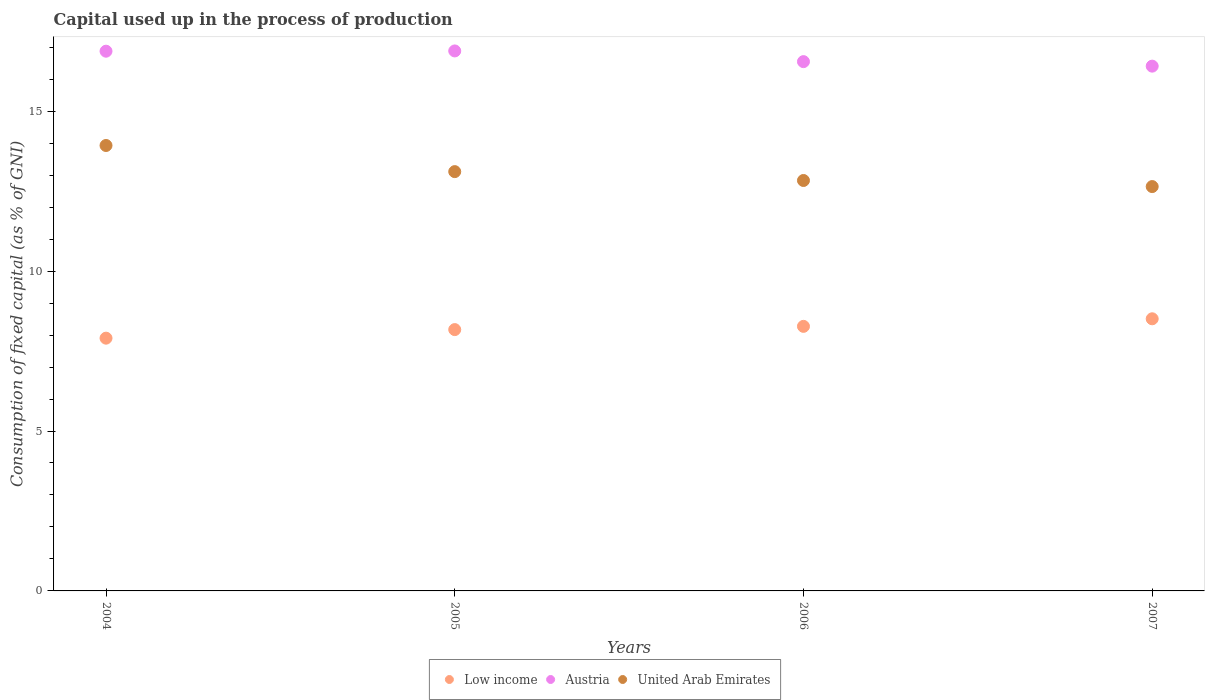What is the capital used up in the process of production in United Arab Emirates in 2005?
Your answer should be compact. 13.11. Across all years, what is the maximum capital used up in the process of production in United Arab Emirates?
Provide a short and direct response. 13.93. Across all years, what is the minimum capital used up in the process of production in United Arab Emirates?
Provide a succinct answer. 12.64. In which year was the capital used up in the process of production in United Arab Emirates minimum?
Keep it short and to the point. 2007. What is the total capital used up in the process of production in United Arab Emirates in the graph?
Provide a short and direct response. 52.51. What is the difference between the capital used up in the process of production in Austria in 2005 and that in 2007?
Provide a succinct answer. 0.48. What is the difference between the capital used up in the process of production in United Arab Emirates in 2006 and the capital used up in the process of production in Low income in 2007?
Provide a short and direct response. 4.32. What is the average capital used up in the process of production in Low income per year?
Make the answer very short. 8.21. In the year 2006, what is the difference between the capital used up in the process of production in Low income and capital used up in the process of production in Austria?
Keep it short and to the point. -8.28. What is the ratio of the capital used up in the process of production in Low income in 2005 to that in 2006?
Make the answer very short. 0.99. Is the capital used up in the process of production in Austria in 2004 less than that in 2007?
Provide a succinct answer. No. What is the difference between the highest and the second highest capital used up in the process of production in Austria?
Your response must be concise. 0.01. What is the difference between the highest and the lowest capital used up in the process of production in Austria?
Your answer should be very brief. 0.48. In how many years, is the capital used up in the process of production in United Arab Emirates greater than the average capital used up in the process of production in United Arab Emirates taken over all years?
Keep it short and to the point. 1. Is the sum of the capital used up in the process of production in United Arab Emirates in 2005 and 2007 greater than the maximum capital used up in the process of production in Low income across all years?
Ensure brevity in your answer.  Yes. Is it the case that in every year, the sum of the capital used up in the process of production in United Arab Emirates and capital used up in the process of production in Low income  is greater than the capital used up in the process of production in Austria?
Keep it short and to the point. Yes. Is the capital used up in the process of production in United Arab Emirates strictly greater than the capital used up in the process of production in Austria over the years?
Your answer should be very brief. No. Is the capital used up in the process of production in Low income strictly less than the capital used up in the process of production in Austria over the years?
Your answer should be compact. Yes. How many dotlines are there?
Make the answer very short. 3. How many years are there in the graph?
Ensure brevity in your answer.  4. Does the graph contain grids?
Offer a terse response. No. Where does the legend appear in the graph?
Give a very brief answer. Bottom center. How are the legend labels stacked?
Your answer should be compact. Horizontal. What is the title of the graph?
Your answer should be compact. Capital used up in the process of production. What is the label or title of the X-axis?
Provide a short and direct response. Years. What is the label or title of the Y-axis?
Give a very brief answer. Consumption of fixed capital (as % of GNI). What is the Consumption of fixed capital (as % of GNI) in Low income in 2004?
Give a very brief answer. 7.9. What is the Consumption of fixed capital (as % of GNI) of Austria in 2004?
Give a very brief answer. 16.88. What is the Consumption of fixed capital (as % of GNI) in United Arab Emirates in 2004?
Offer a very short reply. 13.93. What is the Consumption of fixed capital (as % of GNI) of Low income in 2005?
Provide a short and direct response. 8.17. What is the Consumption of fixed capital (as % of GNI) of Austria in 2005?
Your answer should be compact. 16.88. What is the Consumption of fixed capital (as % of GNI) of United Arab Emirates in 2005?
Keep it short and to the point. 13.11. What is the Consumption of fixed capital (as % of GNI) of Low income in 2006?
Your response must be concise. 8.27. What is the Consumption of fixed capital (as % of GNI) in Austria in 2006?
Keep it short and to the point. 16.55. What is the Consumption of fixed capital (as % of GNI) of United Arab Emirates in 2006?
Your answer should be very brief. 12.83. What is the Consumption of fixed capital (as % of GNI) in Low income in 2007?
Provide a short and direct response. 8.51. What is the Consumption of fixed capital (as % of GNI) in Austria in 2007?
Keep it short and to the point. 16.41. What is the Consumption of fixed capital (as % of GNI) in United Arab Emirates in 2007?
Ensure brevity in your answer.  12.64. Across all years, what is the maximum Consumption of fixed capital (as % of GNI) of Low income?
Keep it short and to the point. 8.51. Across all years, what is the maximum Consumption of fixed capital (as % of GNI) of Austria?
Your answer should be very brief. 16.88. Across all years, what is the maximum Consumption of fixed capital (as % of GNI) of United Arab Emirates?
Your response must be concise. 13.93. Across all years, what is the minimum Consumption of fixed capital (as % of GNI) of Low income?
Provide a succinct answer. 7.9. Across all years, what is the minimum Consumption of fixed capital (as % of GNI) of Austria?
Your response must be concise. 16.41. Across all years, what is the minimum Consumption of fixed capital (as % of GNI) in United Arab Emirates?
Ensure brevity in your answer.  12.64. What is the total Consumption of fixed capital (as % of GNI) of Low income in the graph?
Ensure brevity in your answer.  32.85. What is the total Consumption of fixed capital (as % of GNI) of Austria in the graph?
Make the answer very short. 66.72. What is the total Consumption of fixed capital (as % of GNI) in United Arab Emirates in the graph?
Keep it short and to the point. 52.51. What is the difference between the Consumption of fixed capital (as % of GNI) of Low income in 2004 and that in 2005?
Your response must be concise. -0.27. What is the difference between the Consumption of fixed capital (as % of GNI) of Austria in 2004 and that in 2005?
Your answer should be very brief. -0.01. What is the difference between the Consumption of fixed capital (as % of GNI) in United Arab Emirates in 2004 and that in 2005?
Keep it short and to the point. 0.82. What is the difference between the Consumption of fixed capital (as % of GNI) in Low income in 2004 and that in 2006?
Provide a succinct answer. -0.37. What is the difference between the Consumption of fixed capital (as % of GNI) in Austria in 2004 and that in 2006?
Provide a succinct answer. 0.33. What is the difference between the Consumption of fixed capital (as % of GNI) of United Arab Emirates in 2004 and that in 2006?
Your response must be concise. 1.09. What is the difference between the Consumption of fixed capital (as % of GNI) of Low income in 2004 and that in 2007?
Your answer should be very brief. -0.61. What is the difference between the Consumption of fixed capital (as % of GNI) of Austria in 2004 and that in 2007?
Give a very brief answer. 0.47. What is the difference between the Consumption of fixed capital (as % of GNI) in United Arab Emirates in 2004 and that in 2007?
Your answer should be compact. 1.28. What is the difference between the Consumption of fixed capital (as % of GNI) of Low income in 2005 and that in 2006?
Offer a very short reply. -0.1. What is the difference between the Consumption of fixed capital (as % of GNI) of Austria in 2005 and that in 2006?
Provide a short and direct response. 0.33. What is the difference between the Consumption of fixed capital (as % of GNI) in United Arab Emirates in 2005 and that in 2006?
Your answer should be compact. 0.28. What is the difference between the Consumption of fixed capital (as % of GNI) of Low income in 2005 and that in 2007?
Ensure brevity in your answer.  -0.34. What is the difference between the Consumption of fixed capital (as % of GNI) in Austria in 2005 and that in 2007?
Give a very brief answer. 0.48. What is the difference between the Consumption of fixed capital (as % of GNI) of United Arab Emirates in 2005 and that in 2007?
Your response must be concise. 0.47. What is the difference between the Consumption of fixed capital (as % of GNI) in Low income in 2006 and that in 2007?
Your answer should be very brief. -0.24. What is the difference between the Consumption of fixed capital (as % of GNI) in Austria in 2006 and that in 2007?
Give a very brief answer. 0.14. What is the difference between the Consumption of fixed capital (as % of GNI) in United Arab Emirates in 2006 and that in 2007?
Offer a terse response. 0.19. What is the difference between the Consumption of fixed capital (as % of GNI) of Low income in 2004 and the Consumption of fixed capital (as % of GNI) of Austria in 2005?
Provide a short and direct response. -8.98. What is the difference between the Consumption of fixed capital (as % of GNI) of Low income in 2004 and the Consumption of fixed capital (as % of GNI) of United Arab Emirates in 2005?
Your response must be concise. -5.21. What is the difference between the Consumption of fixed capital (as % of GNI) of Austria in 2004 and the Consumption of fixed capital (as % of GNI) of United Arab Emirates in 2005?
Give a very brief answer. 3.77. What is the difference between the Consumption of fixed capital (as % of GNI) in Low income in 2004 and the Consumption of fixed capital (as % of GNI) in Austria in 2006?
Ensure brevity in your answer.  -8.65. What is the difference between the Consumption of fixed capital (as % of GNI) in Low income in 2004 and the Consumption of fixed capital (as % of GNI) in United Arab Emirates in 2006?
Your answer should be compact. -4.93. What is the difference between the Consumption of fixed capital (as % of GNI) of Austria in 2004 and the Consumption of fixed capital (as % of GNI) of United Arab Emirates in 2006?
Your answer should be very brief. 4.04. What is the difference between the Consumption of fixed capital (as % of GNI) of Low income in 2004 and the Consumption of fixed capital (as % of GNI) of Austria in 2007?
Provide a succinct answer. -8.51. What is the difference between the Consumption of fixed capital (as % of GNI) in Low income in 2004 and the Consumption of fixed capital (as % of GNI) in United Arab Emirates in 2007?
Make the answer very short. -4.74. What is the difference between the Consumption of fixed capital (as % of GNI) of Austria in 2004 and the Consumption of fixed capital (as % of GNI) of United Arab Emirates in 2007?
Make the answer very short. 4.23. What is the difference between the Consumption of fixed capital (as % of GNI) in Low income in 2005 and the Consumption of fixed capital (as % of GNI) in Austria in 2006?
Provide a succinct answer. -8.38. What is the difference between the Consumption of fixed capital (as % of GNI) of Low income in 2005 and the Consumption of fixed capital (as % of GNI) of United Arab Emirates in 2006?
Keep it short and to the point. -4.66. What is the difference between the Consumption of fixed capital (as % of GNI) in Austria in 2005 and the Consumption of fixed capital (as % of GNI) in United Arab Emirates in 2006?
Your answer should be compact. 4.05. What is the difference between the Consumption of fixed capital (as % of GNI) of Low income in 2005 and the Consumption of fixed capital (as % of GNI) of Austria in 2007?
Ensure brevity in your answer.  -8.24. What is the difference between the Consumption of fixed capital (as % of GNI) of Low income in 2005 and the Consumption of fixed capital (as % of GNI) of United Arab Emirates in 2007?
Your response must be concise. -4.47. What is the difference between the Consumption of fixed capital (as % of GNI) of Austria in 2005 and the Consumption of fixed capital (as % of GNI) of United Arab Emirates in 2007?
Ensure brevity in your answer.  4.24. What is the difference between the Consumption of fixed capital (as % of GNI) in Low income in 2006 and the Consumption of fixed capital (as % of GNI) in Austria in 2007?
Provide a succinct answer. -8.14. What is the difference between the Consumption of fixed capital (as % of GNI) of Low income in 2006 and the Consumption of fixed capital (as % of GNI) of United Arab Emirates in 2007?
Make the answer very short. -4.37. What is the difference between the Consumption of fixed capital (as % of GNI) of Austria in 2006 and the Consumption of fixed capital (as % of GNI) of United Arab Emirates in 2007?
Your answer should be compact. 3.91. What is the average Consumption of fixed capital (as % of GNI) of Low income per year?
Provide a succinct answer. 8.21. What is the average Consumption of fixed capital (as % of GNI) of Austria per year?
Make the answer very short. 16.68. What is the average Consumption of fixed capital (as % of GNI) of United Arab Emirates per year?
Your answer should be very brief. 13.13. In the year 2004, what is the difference between the Consumption of fixed capital (as % of GNI) of Low income and Consumption of fixed capital (as % of GNI) of Austria?
Offer a terse response. -8.97. In the year 2004, what is the difference between the Consumption of fixed capital (as % of GNI) in Low income and Consumption of fixed capital (as % of GNI) in United Arab Emirates?
Provide a short and direct response. -6.02. In the year 2004, what is the difference between the Consumption of fixed capital (as % of GNI) of Austria and Consumption of fixed capital (as % of GNI) of United Arab Emirates?
Ensure brevity in your answer.  2.95. In the year 2005, what is the difference between the Consumption of fixed capital (as % of GNI) in Low income and Consumption of fixed capital (as % of GNI) in Austria?
Make the answer very short. -8.71. In the year 2005, what is the difference between the Consumption of fixed capital (as % of GNI) of Low income and Consumption of fixed capital (as % of GNI) of United Arab Emirates?
Ensure brevity in your answer.  -4.94. In the year 2005, what is the difference between the Consumption of fixed capital (as % of GNI) in Austria and Consumption of fixed capital (as % of GNI) in United Arab Emirates?
Provide a short and direct response. 3.77. In the year 2006, what is the difference between the Consumption of fixed capital (as % of GNI) in Low income and Consumption of fixed capital (as % of GNI) in Austria?
Your answer should be very brief. -8.28. In the year 2006, what is the difference between the Consumption of fixed capital (as % of GNI) in Low income and Consumption of fixed capital (as % of GNI) in United Arab Emirates?
Your answer should be compact. -4.56. In the year 2006, what is the difference between the Consumption of fixed capital (as % of GNI) in Austria and Consumption of fixed capital (as % of GNI) in United Arab Emirates?
Your answer should be compact. 3.72. In the year 2007, what is the difference between the Consumption of fixed capital (as % of GNI) in Low income and Consumption of fixed capital (as % of GNI) in Austria?
Offer a very short reply. -7.9. In the year 2007, what is the difference between the Consumption of fixed capital (as % of GNI) in Low income and Consumption of fixed capital (as % of GNI) in United Arab Emirates?
Give a very brief answer. -4.13. In the year 2007, what is the difference between the Consumption of fixed capital (as % of GNI) in Austria and Consumption of fixed capital (as % of GNI) in United Arab Emirates?
Offer a very short reply. 3.77. What is the ratio of the Consumption of fixed capital (as % of GNI) of Low income in 2004 to that in 2005?
Give a very brief answer. 0.97. What is the ratio of the Consumption of fixed capital (as % of GNI) of Austria in 2004 to that in 2005?
Provide a succinct answer. 1. What is the ratio of the Consumption of fixed capital (as % of GNI) of United Arab Emirates in 2004 to that in 2005?
Your response must be concise. 1.06. What is the ratio of the Consumption of fixed capital (as % of GNI) of Low income in 2004 to that in 2006?
Give a very brief answer. 0.96. What is the ratio of the Consumption of fixed capital (as % of GNI) of Austria in 2004 to that in 2006?
Your answer should be compact. 1.02. What is the ratio of the Consumption of fixed capital (as % of GNI) of United Arab Emirates in 2004 to that in 2006?
Ensure brevity in your answer.  1.09. What is the ratio of the Consumption of fixed capital (as % of GNI) in Low income in 2004 to that in 2007?
Offer a very short reply. 0.93. What is the ratio of the Consumption of fixed capital (as % of GNI) of Austria in 2004 to that in 2007?
Your answer should be very brief. 1.03. What is the ratio of the Consumption of fixed capital (as % of GNI) in United Arab Emirates in 2004 to that in 2007?
Your answer should be compact. 1.1. What is the ratio of the Consumption of fixed capital (as % of GNI) of Austria in 2005 to that in 2006?
Provide a succinct answer. 1.02. What is the ratio of the Consumption of fixed capital (as % of GNI) of United Arab Emirates in 2005 to that in 2006?
Offer a terse response. 1.02. What is the ratio of the Consumption of fixed capital (as % of GNI) in Low income in 2005 to that in 2007?
Provide a short and direct response. 0.96. What is the ratio of the Consumption of fixed capital (as % of GNI) in United Arab Emirates in 2005 to that in 2007?
Make the answer very short. 1.04. What is the ratio of the Consumption of fixed capital (as % of GNI) of Low income in 2006 to that in 2007?
Provide a short and direct response. 0.97. What is the ratio of the Consumption of fixed capital (as % of GNI) in Austria in 2006 to that in 2007?
Keep it short and to the point. 1.01. What is the ratio of the Consumption of fixed capital (as % of GNI) of United Arab Emirates in 2006 to that in 2007?
Give a very brief answer. 1.01. What is the difference between the highest and the second highest Consumption of fixed capital (as % of GNI) of Low income?
Provide a succinct answer. 0.24. What is the difference between the highest and the second highest Consumption of fixed capital (as % of GNI) of Austria?
Offer a terse response. 0.01. What is the difference between the highest and the second highest Consumption of fixed capital (as % of GNI) in United Arab Emirates?
Keep it short and to the point. 0.82. What is the difference between the highest and the lowest Consumption of fixed capital (as % of GNI) in Low income?
Keep it short and to the point. 0.61. What is the difference between the highest and the lowest Consumption of fixed capital (as % of GNI) in Austria?
Keep it short and to the point. 0.48. What is the difference between the highest and the lowest Consumption of fixed capital (as % of GNI) of United Arab Emirates?
Provide a short and direct response. 1.28. 